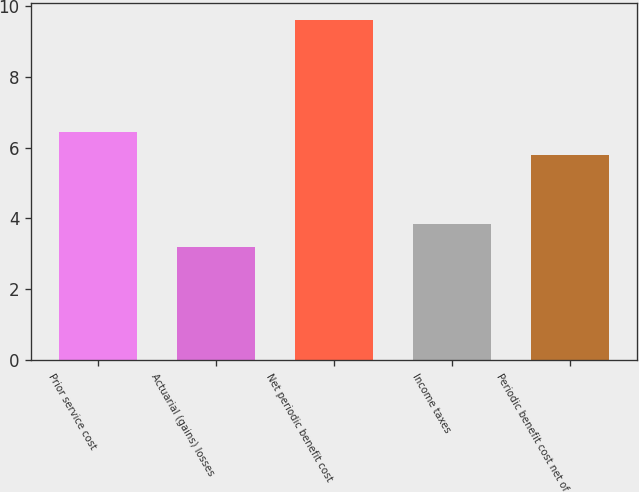Convert chart to OTSL. <chart><loc_0><loc_0><loc_500><loc_500><bar_chart><fcel>Prior service cost<fcel>Actuarial (gains) losses<fcel>Net periodic benefit cost<fcel>Income taxes<fcel>Periodic benefit cost net of<nl><fcel>6.44<fcel>3.2<fcel>9.6<fcel>3.84<fcel>5.8<nl></chart> 